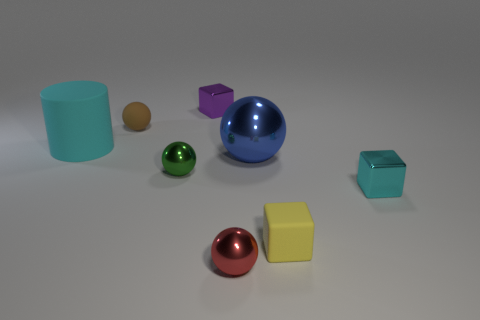Add 1 tiny shiny objects. How many objects exist? 9 Subtract all cylinders. How many objects are left? 7 Add 6 green objects. How many green objects are left? 7 Add 3 purple shiny things. How many purple shiny things exist? 4 Subtract 1 green balls. How many objects are left? 7 Subtract all big purple cubes. Subtract all tiny green things. How many objects are left? 7 